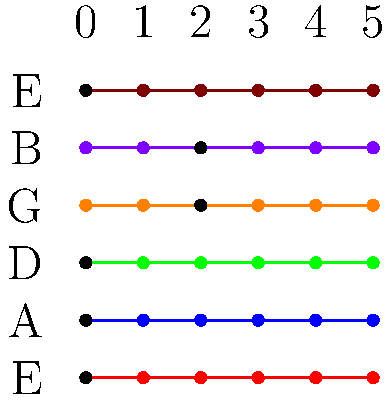What chord is represented by the tablature notation shown in the image? To determine the chord represented by the tablature notation, we need to follow these steps:

1. Identify the notes being played on each string:
   - High E string (top): 0 (open string) = E
   - B string: 2nd fret = C#
   - G string: 2nd fret = A
   - D string: 0 (open string) = D
   - A string: 0 (open string) = A
   - Low E string: 0 (open string) = E

2. Analyze the notes: E, C#, A, D, A, E

3. Recognize the chord structure:
   - The root note is A (appears twice)
   - The third is C# (major third)
   - The fifth is E (appears twice)
   - There's an additional D note, which is the fourth

4. Conclude the chord type:
   This combination of notes forms an A major chord with an added fourth (D), commonly notated as Aadd4 or A(add4).

The presence of the open low E string adds a rich, full sound typical in rock music, making this an A major chord with added depth and complexity.
Answer: Aadd4 